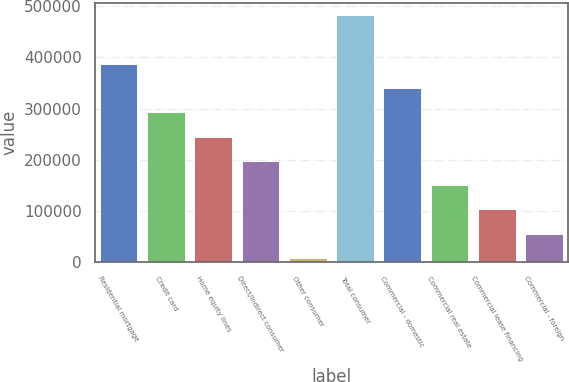Convert chart. <chart><loc_0><loc_0><loc_500><loc_500><bar_chart><fcel>Residential mortgage<fcel>Credit card<fcel>Home equity lines<fcel>Direct/Indirect consumer<fcel>Other consumer<fcel>Total consumer<fcel>Commercial - domestic<fcel>Commercial real estate<fcel>Commercial lease financing<fcel>Commercial - foreign<nl><fcel>387804<fcel>292782<fcel>245272<fcel>197761<fcel>7717<fcel>482826<fcel>340293<fcel>150250<fcel>102739<fcel>55227.9<nl></chart> 